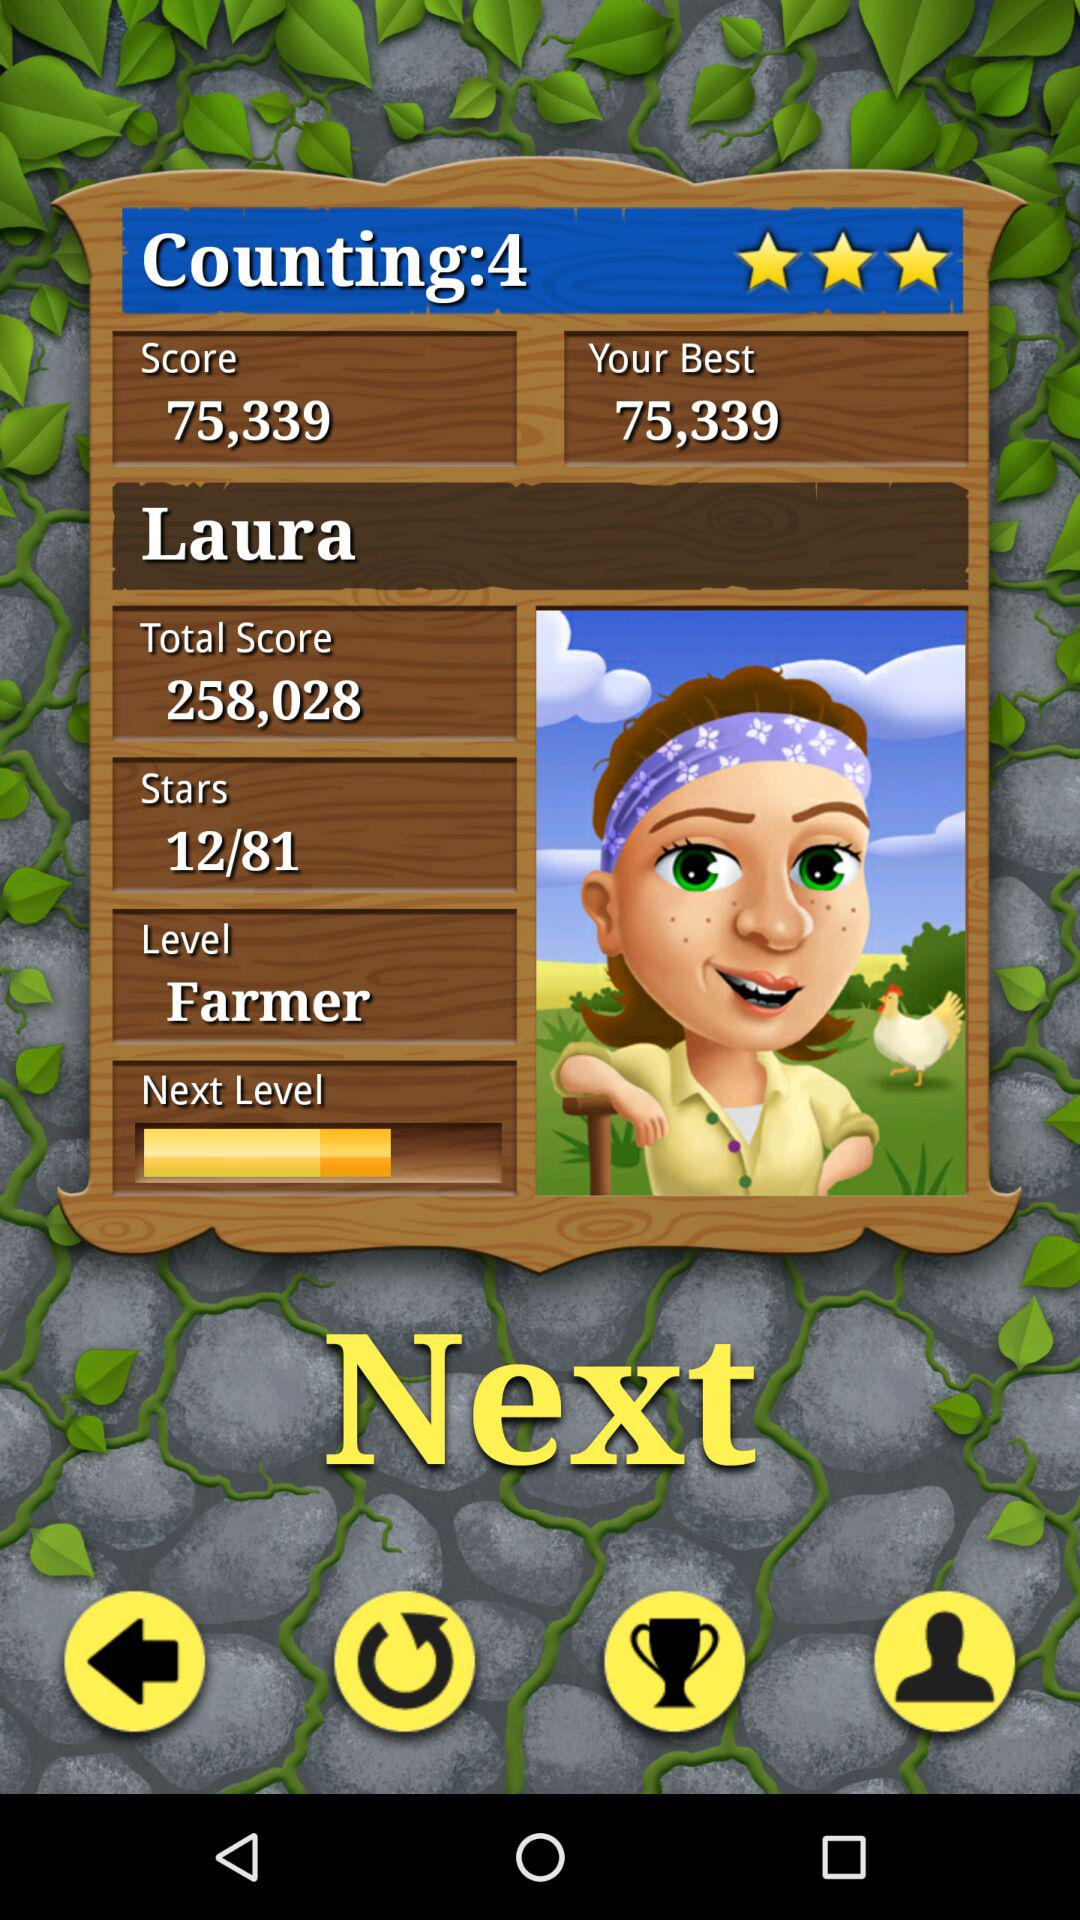What is the level? The level is "Farmer". 